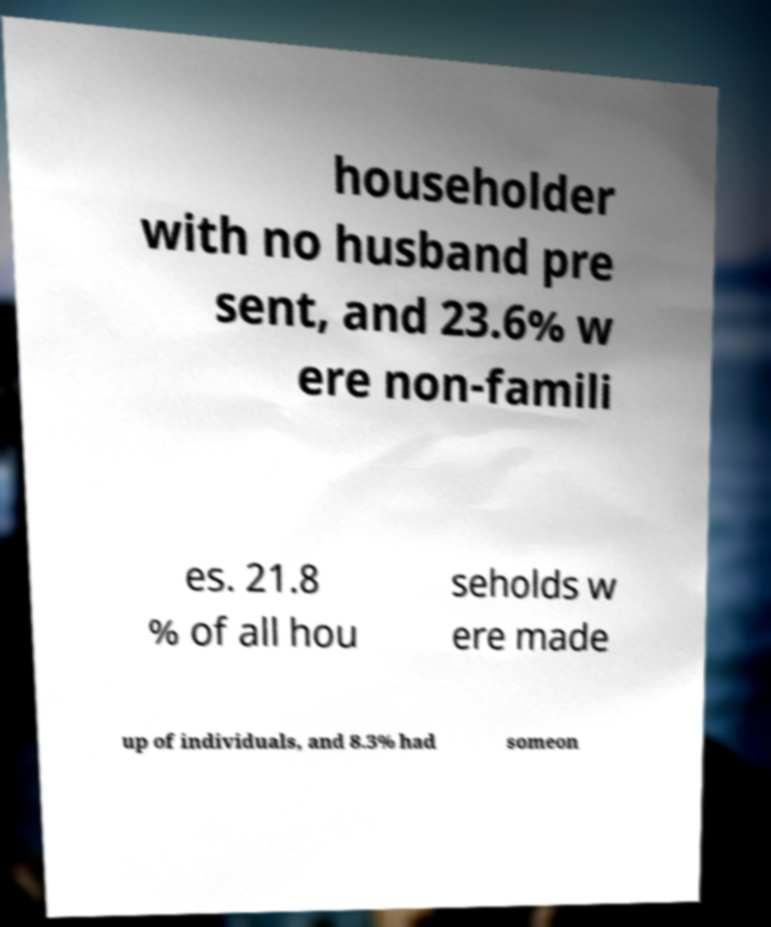I need the written content from this picture converted into text. Can you do that? householder with no husband pre sent, and 23.6% w ere non-famili es. 21.8 % of all hou seholds w ere made up of individuals, and 8.3% had someon 